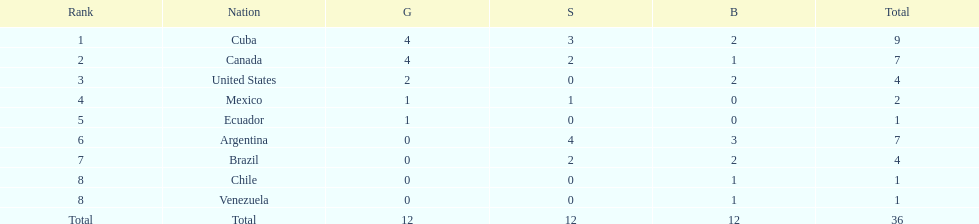Would you mind parsing the complete table? {'header': ['Rank', 'Nation', 'G', 'S', 'B', 'Total'], 'rows': [['1', 'Cuba', '4', '3', '2', '9'], ['2', 'Canada', '4', '2', '1', '7'], ['3', 'United States', '2', '0', '2', '4'], ['4', 'Mexico', '1', '1', '0', '2'], ['5', 'Ecuador', '1', '0', '0', '1'], ['6', 'Argentina', '0', '4', '3', '7'], ['7', 'Brazil', '0', '2', '2', '4'], ['8', 'Chile', '0', '0', '1', '1'], ['8', 'Venezuela', '0', '0', '1', '1'], ['Total', 'Total', '12', '12', '12', '36']]} Which ranking is mexico? 4. 